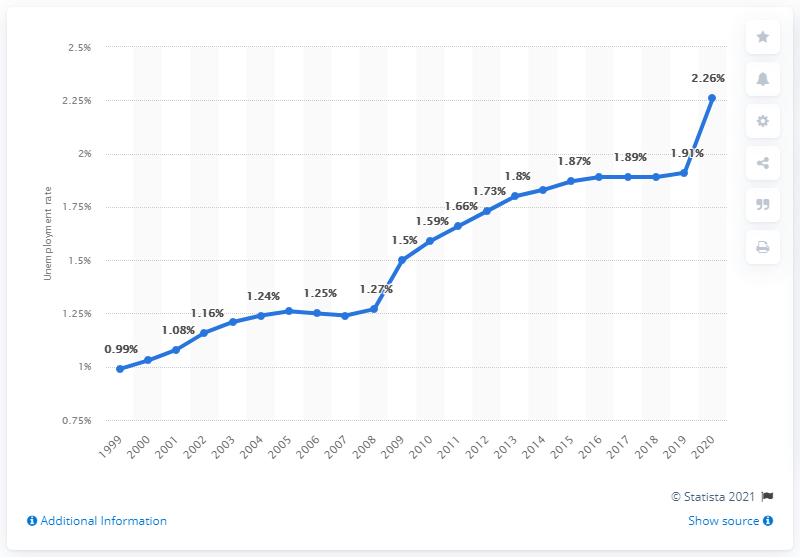Specify some key components in this picture. The unemployment rate in Chad in 2020 was 2.26%. 